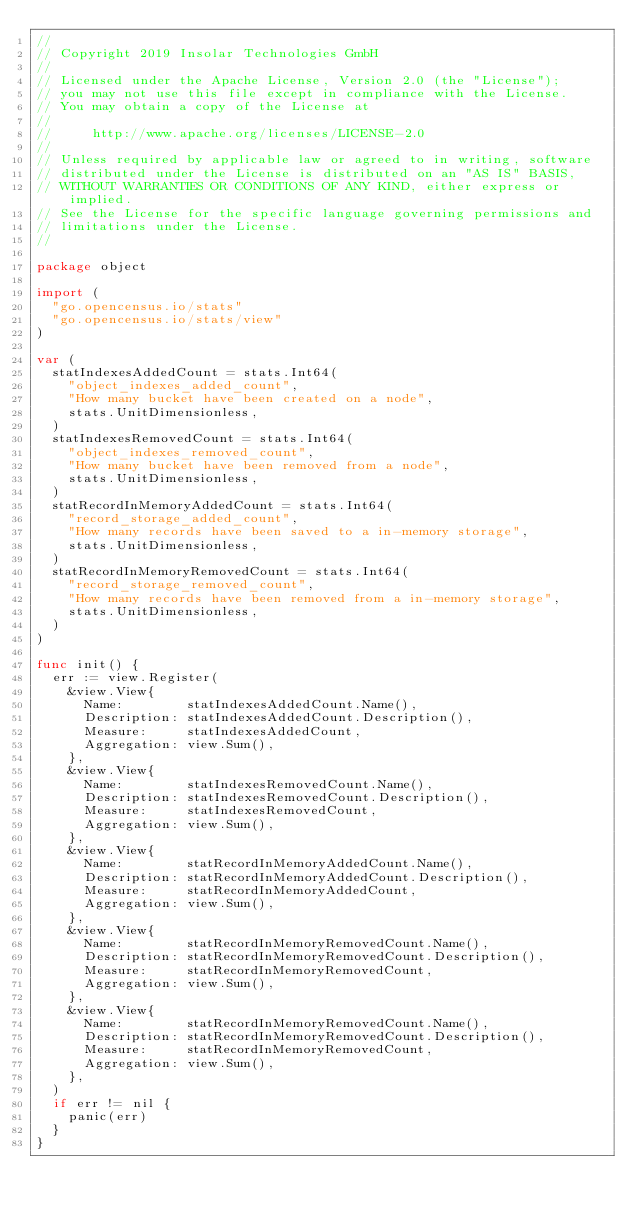Convert code to text. <code><loc_0><loc_0><loc_500><loc_500><_Go_>//
// Copyright 2019 Insolar Technologies GmbH
//
// Licensed under the Apache License, Version 2.0 (the "License");
// you may not use this file except in compliance with the License.
// You may obtain a copy of the License at
//
//     http://www.apache.org/licenses/LICENSE-2.0
//
// Unless required by applicable law or agreed to in writing, software
// distributed under the License is distributed on an "AS IS" BASIS,
// WITHOUT WARRANTIES OR CONDITIONS OF ANY KIND, either express or implied.
// See the License for the specific language governing permissions and
// limitations under the License.
//

package object

import (
	"go.opencensus.io/stats"
	"go.opencensus.io/stats/view"
)

var (
	statIndexesAddedCount = stats.Int64(
		"object_indexes_added_count",
		"How many bucket have been created on a node",
		stats.UnitDimensionless,
	)
	statIndexesRemovedCount = stats.Int64(
		"object_indexes_removed_count",
		"How many bucket have been removed from a node",
		stats.UnitDimensionless,
	)
	statRecordInMemoryAddedCount = stats.Int64(
		"record_storage_added_count",
		"How many records have been saved to a in-memory storage",
		stats.UnitDimensionless,
	)
	statRecordInMemoryRemovedCount = stats.Int64(
		"record_storage_removed_count",
		"How many records have been removed from a in-memory storage",
		stats.UnitDimensionless,
	)
)

func init() {
	err := view.Register(
		&view.View{
			Name:        statIndexesAddedCount.Name(),
			Description: statIndexesAddedCount.Description(),
			Measure:     statIndexesAddedCount,
			Aggregation: view.Sum(),
		},
		&view.View{
			Name:        statIndexesRemovedCount.Name(),
			Description: statIndexesRemovedCount.Description(),
			Measure:     statIndexesRemovedCount,
			Aggregation: view.Sum(),
		},
		&view.View{
			Name:        statRecordInMemoryAddedCount.Name(),
			Description: statRecordInMemoryAddedCount.Description(),
			Measure:     statRecordInMemoryAddedCount,
			Aggregation: view.Sum(),
		},
		&view.View{
			Name:        statRecordInMemoryRemovedCount.Name(),
			Description: statRecordInMemoryRemovedCount.Description(),
			Measure:     statRecordInMemoryRemovedCount,
			Aggregation: view.Sum(),
		},
		&view.View{
			Name:        statRecordInMemoryRemovedCount.Name(),
			Description: statRecordInMemoryRemovedCount.Description(),
			Measure:     statRecordInMemoryRemovedCount,
			Aggregation: view.Sum(),
		},
	)
	if err != nil {
		panic(err)
	}
}
</code> 